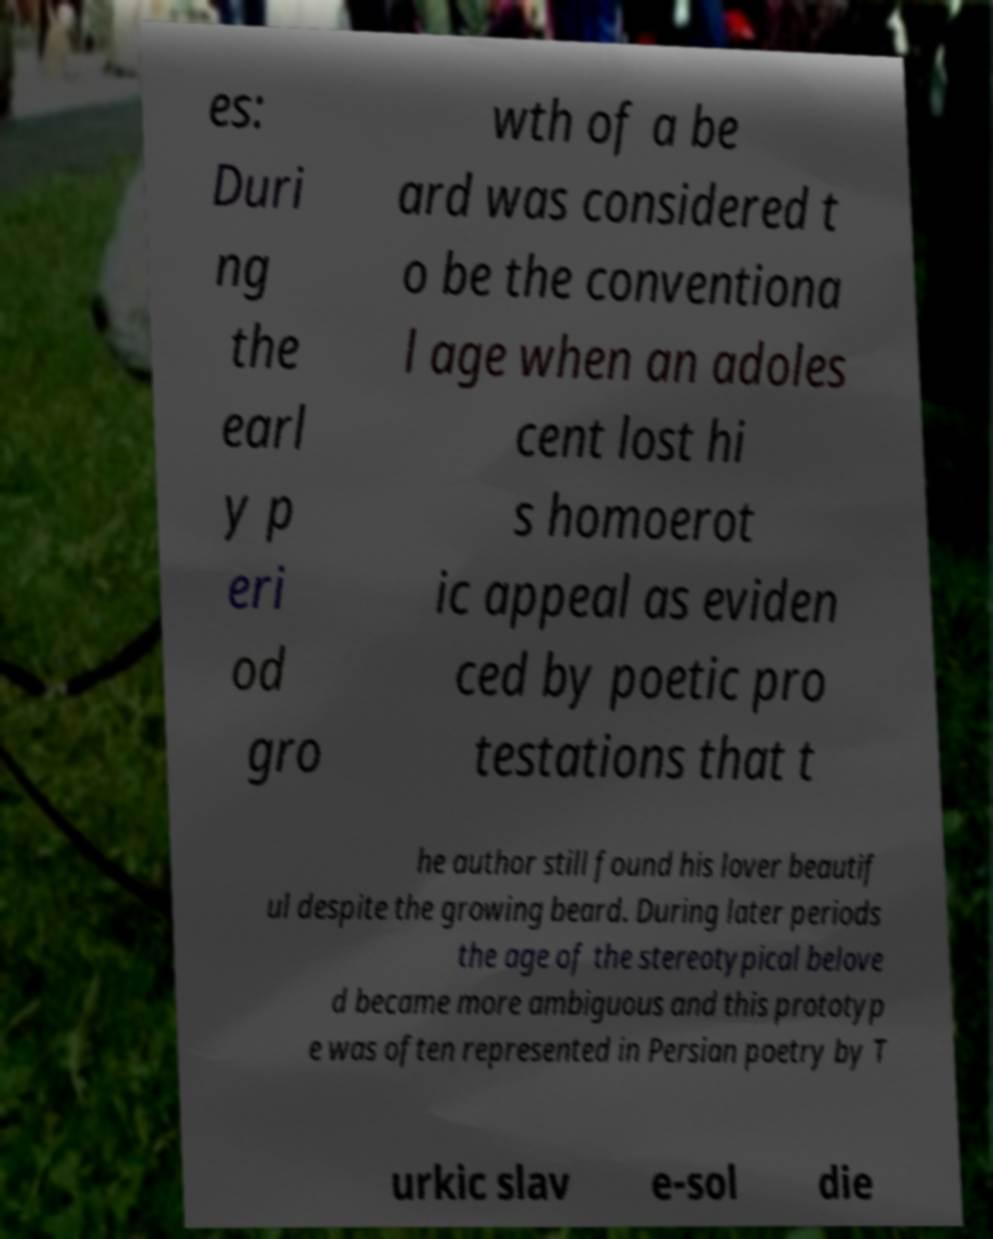What messages or text are displayed in this image? I need them in a readable, typed format. es: Duri ng the earl y p eri od gro wth of a be ard was considered t o be the conventiona l age when an adoles cent lost hi s homoerot ic appeal as eviden ced by poetic pro testations that t he author still found his lover beautif ul despite the growing beard. During later periods the age of the stereotypical belove d became more ambiguous and this prototyp e was often represented in Persian poetry by T urkic slav e-sol die 